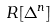Convert formula to latex. <formula><loc_0><loc_0><loc_500><loc_500>R [ \Delta ^ { n } ]</formula> 